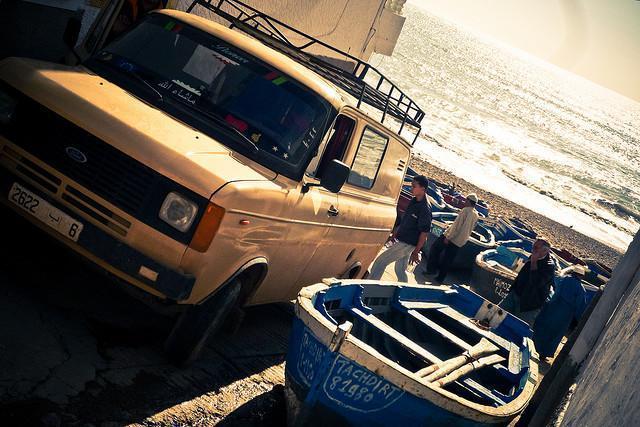How many people are in the picture?
Give a very brief answer. 3. How many boats can you see?
Give a very brief answer. 2. 